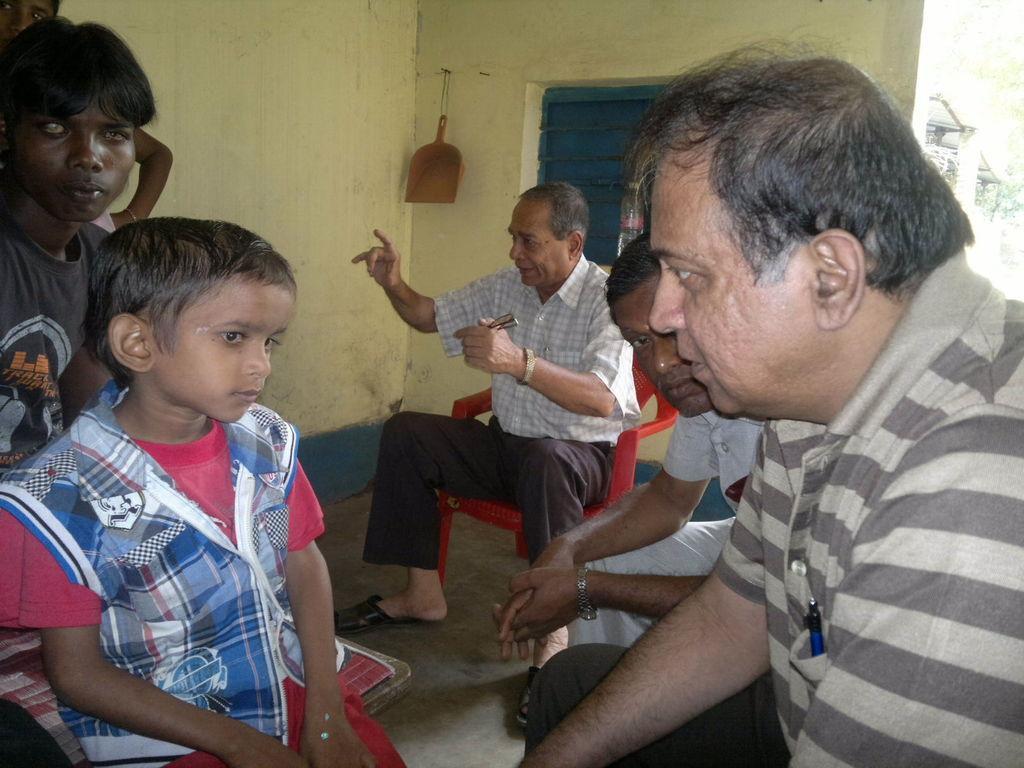Describe this image in one or two sentences. In this picture, we see people sitting on the chairs. The man in the middle of the picture wearing a white shirt is holding spectacles in his hand and he is explaining something. Behind him, we see a blue window and yellow wall. In the right top of the picture, we see trees. This picture is clicked inside the room. 